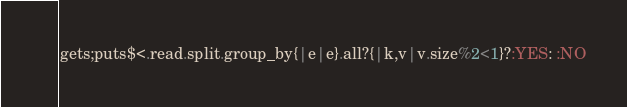Convert code to text. <code><loc_0><loc_0><loc_500><loc_500><_Ruby_>gets;puts$<.read.split.group_by{|e|e}.all?{|k,v|v.size%2<1}?:YES: :NO</code> 